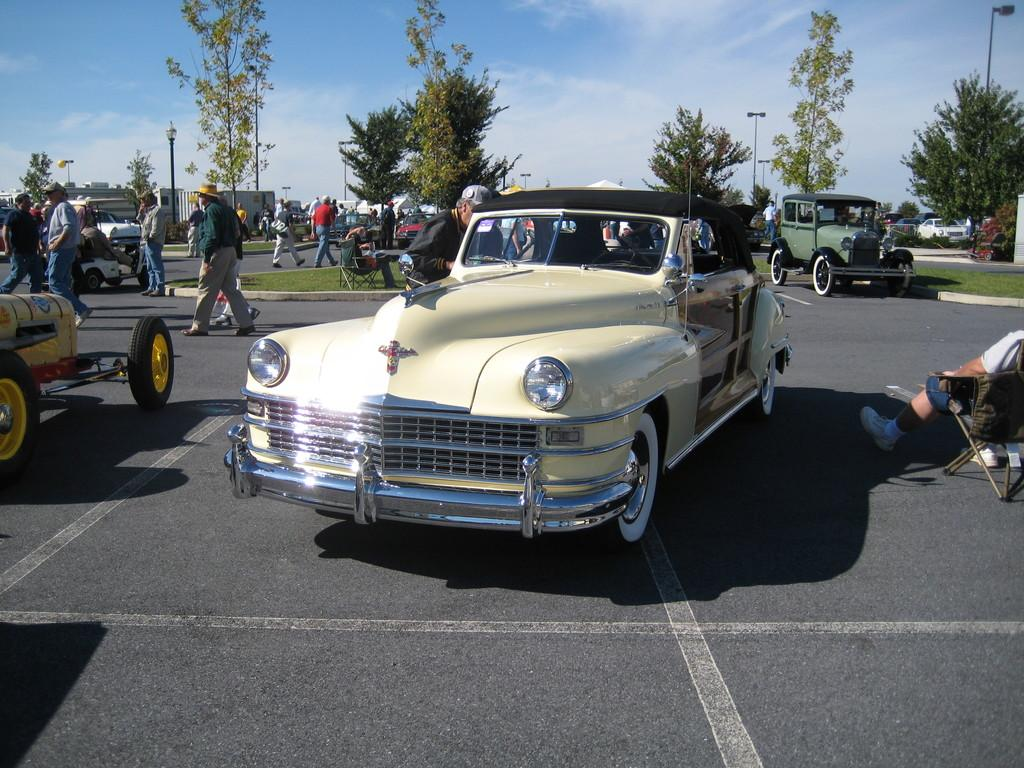What type of vehicles can be seen on the road in the image? There are cars on the road in the image. What are the people in the image doing? The people in the image are walking on the road. What can be seen in the background of the image? There are trees and the sky visible in the background of the image. What type of sand can be seen on the wheels of the cars in the image? There is no sand present in the image, and the cars do not have visible wheels. 